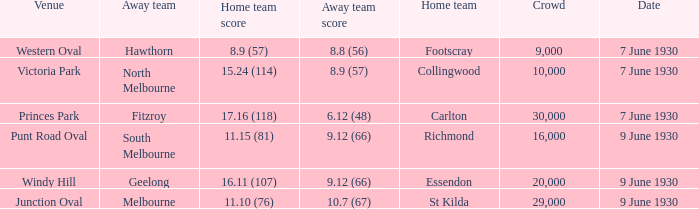Where did the away team score 8.9 (57)? Victoria Park. 